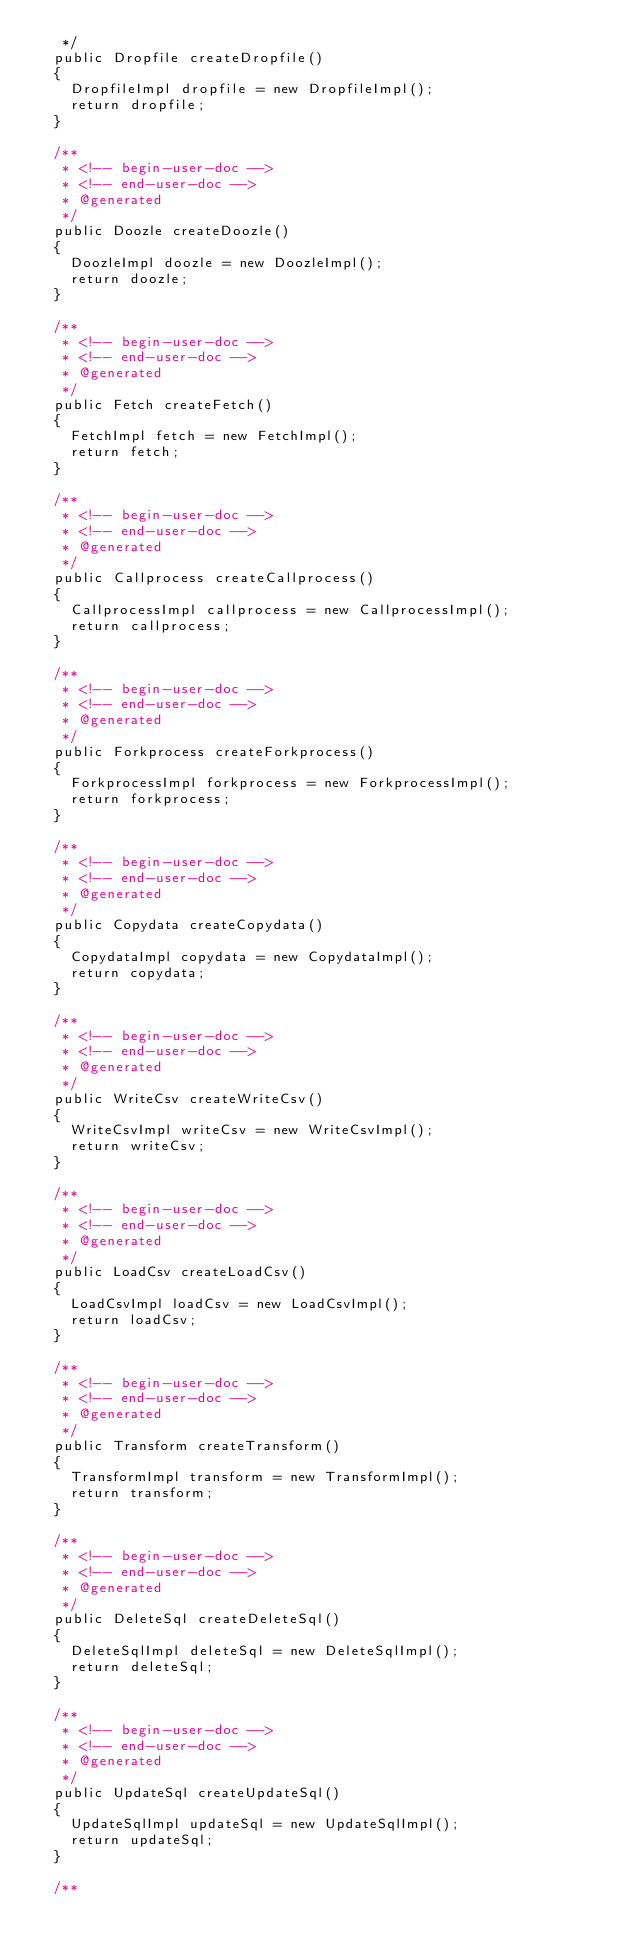Convert code to text. <code><loc_0><loc_0><loc_500><loc_500><_Java_>   */
  public Dropfile createDropfile()
  {
    DropfileImpl dropfile = new DropfileImpl();
    return dropfile;
  }

  /**
   * <!-- begin-user-doc -->
   * <!-- end-user-doc -->
   * @generated
   */
  public Doozle createDoozle()
  {
    DoozleImpl doozle = new DoozleImpl();
    return doozle;
  }

  /**
   * <!-- begin-user-doc -->
   * <!-- end-user-doc -->
   * @generated
   */
  public Fetch createFetch()
  {
    FetchImpl fetch = new FetchImpl();
    return fetch;
  }

  /**
   * <!-- begin-user-doc -->
   * <!-- end-user-doc -->
   * @generated
   */
  public Callprocess createCallprocess()
  {
    CallprocessImpl callprocess = new CallprocessImpl();
    return callprocess;
  }

  /**
   * <!-- begin-user-doc -->
   * <!-- end-user-doc -->
   * @generated
   */
  public Forkprocess createForkprocess()
  {
    ForkprocessImpl forkprocess = new ForkprocessImpl();
    return forkprocess;
  }

  /**
   * <!-- begin-user-doc -->
   * <!-- end-user-doc -->
   * @generated
   */
  public Copydata createCopydata()
  {
    CopydataImpl copydata = new CopydataImpl();
    return copydata;
  }

  /**
   * <!-- begin-user-doc -->
   * <!-- end-user-doc -->
   * @generated
   */
  public WriteCsv createWriteCsv()
  {
    WriteCsvImpl writeCsv = new WriteCsvImpl();
    return writeCsv;
  }

  /**
   * <!-- begin-user-doc -->
   * <!-- end-user-doc -->
   * @generated
   */
  public LoadCsv createLoadCsv()
  {
    LoadCsvImpl loadCsv = new LoadCsvImpl();
    return loadCsv;
  }

  /**
   * <!-- begin-user-doc -->
   * <!-- end-user-doc -->
   * @generated
   */
  public Transform createTransform()
  {
    TransformImpl transform = new TransformImpl();
    return transform;
  }

  /**
   * <!-- begin-user-doc -->
   * <!-- end-user-doc -->
   * @generated
   */
  public DeleteSql createDeleteSql()
  {
    DeleteSqlImpl deleteSql = new DeleteSqlImpl();
    return deleteSql;
  }

  /**
   * <!-- begin-user-doc -->
   * <!-- end-user-doc -->
   * @generated
   */
  public UpdateSql createUpdateSql()
  {
    UpdateSqlImpl updateSql = new UpdateSqlImpl();
    return updateSql;
  }

  /**</code> 